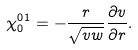Convert formula to latex. <formula><loc_0><loc_0><loc_500><loc_500>\chi _ { 0 } ^ { 0 1 } = - \frac { r } { \sqrt { v w } } \frac { \partial v } { \partial r } .</formula> 